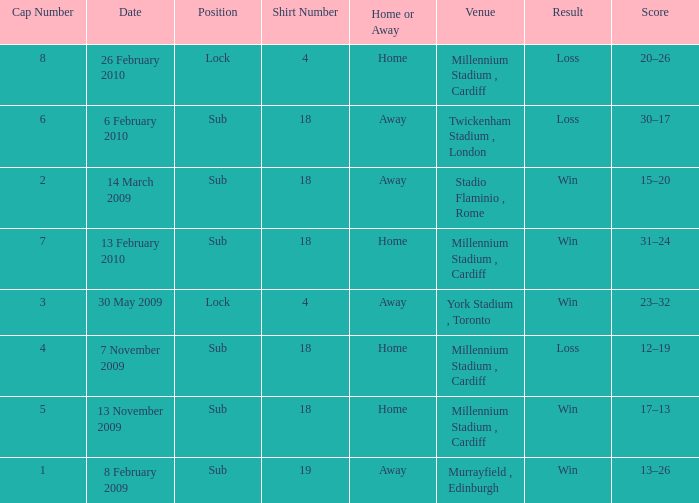Can you tell me the Home or the Away that has the Shirt Number larger than 18? Away. 